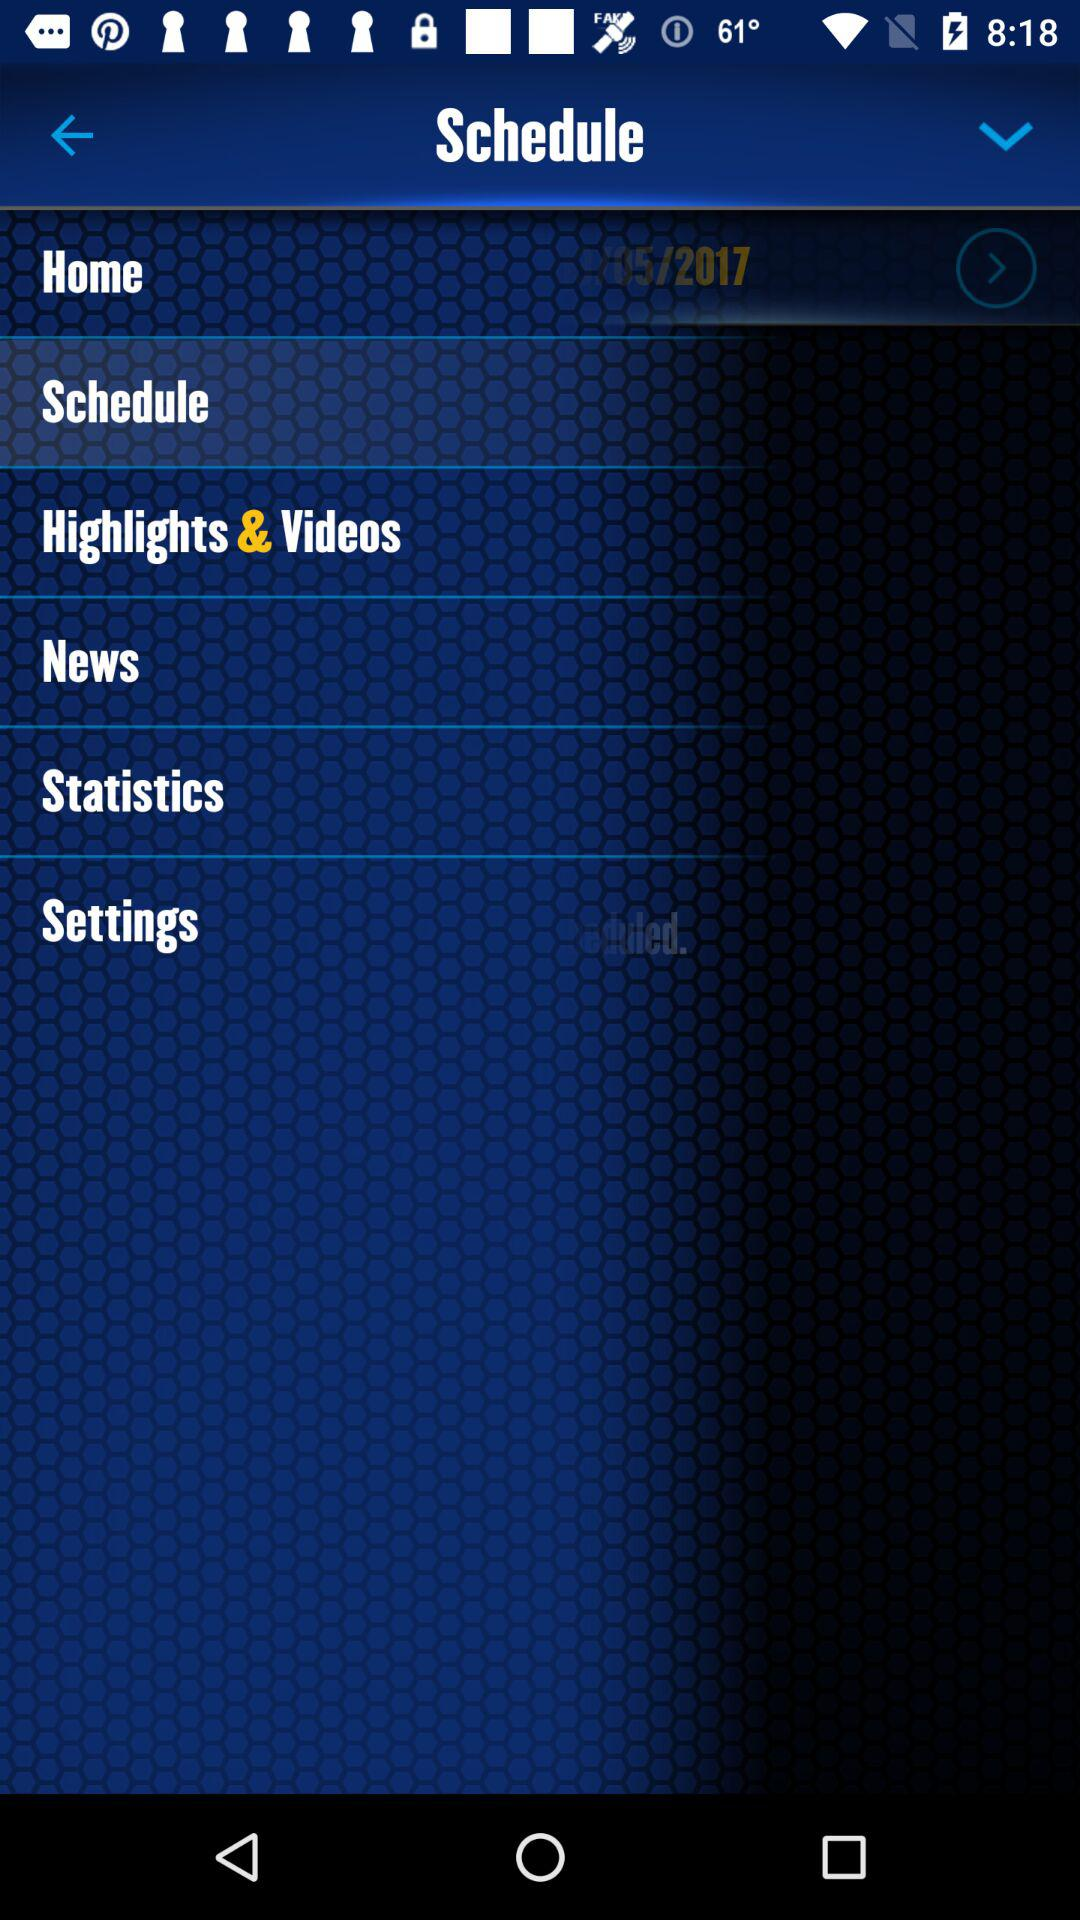What is the mentioned year? The mentioned year is 2017. 